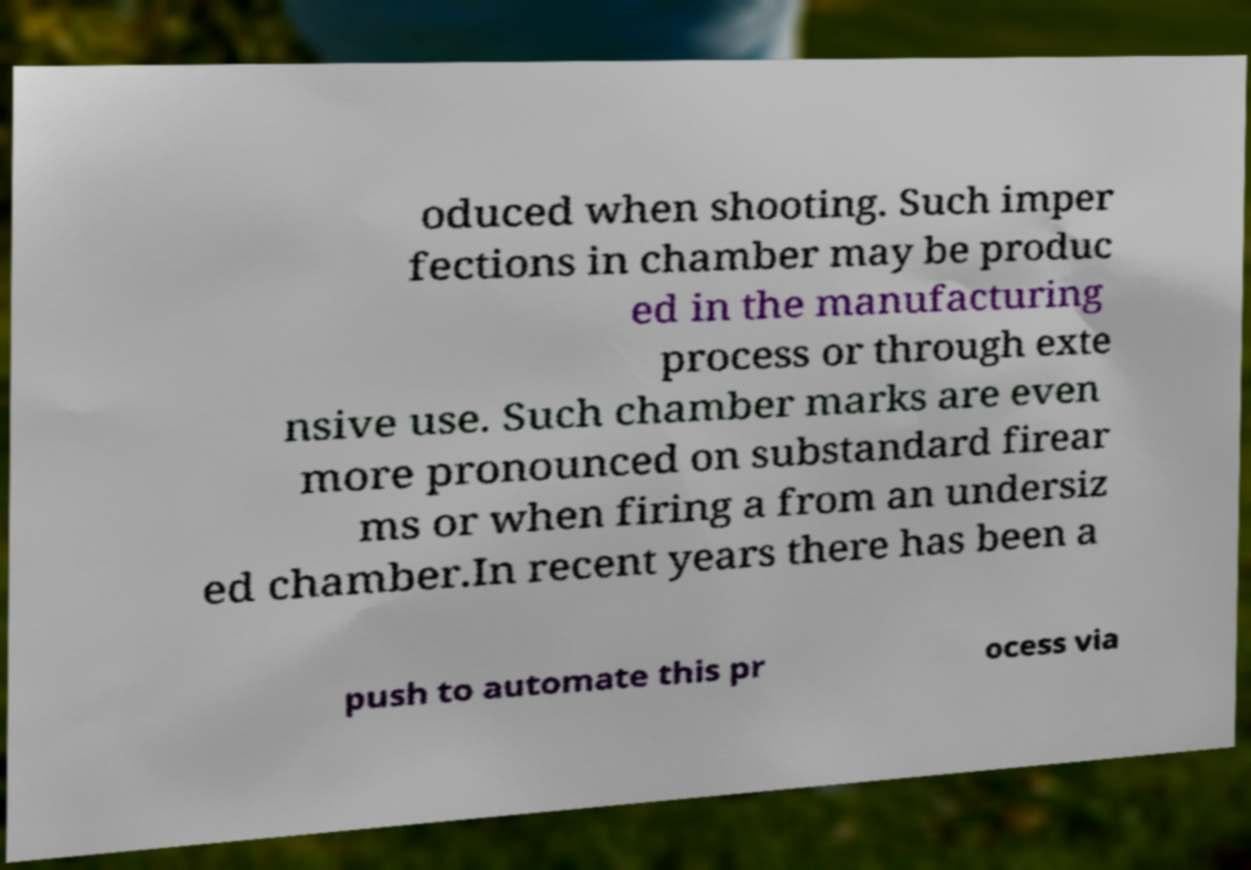What messages or text are displayed in this image? I need them in a readable, typed format. oduced when shooting. Such imper fections in chamber may be produc ed in the manufacturing process or through exte nsive use. Such chamber marks are even more pronounced on substandard firear ms or when firing a from an undersiz ed chamber.In recent years there has been a push to automate this pr ocess via 